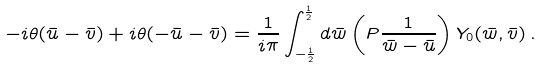Convert formula to latex. <formula><loc_0><loc_0><loc_500><loc_500>- i \theta ( \bar { u } - \bar { v } ) + i \theta ( - \bar { u } - \bar { v } ) = \frac { 1 } { i \pi } \int _ { - \frac { 1 } { 2 } } ^ { \frac { 1 } { 2 } } d \bar { w } \left ( P \frac { 1 } { \bar { w } - \bar { u } } \right ) Y _ { 0 } ( \bar { w } , \bar { v } ) \, .</formula> 